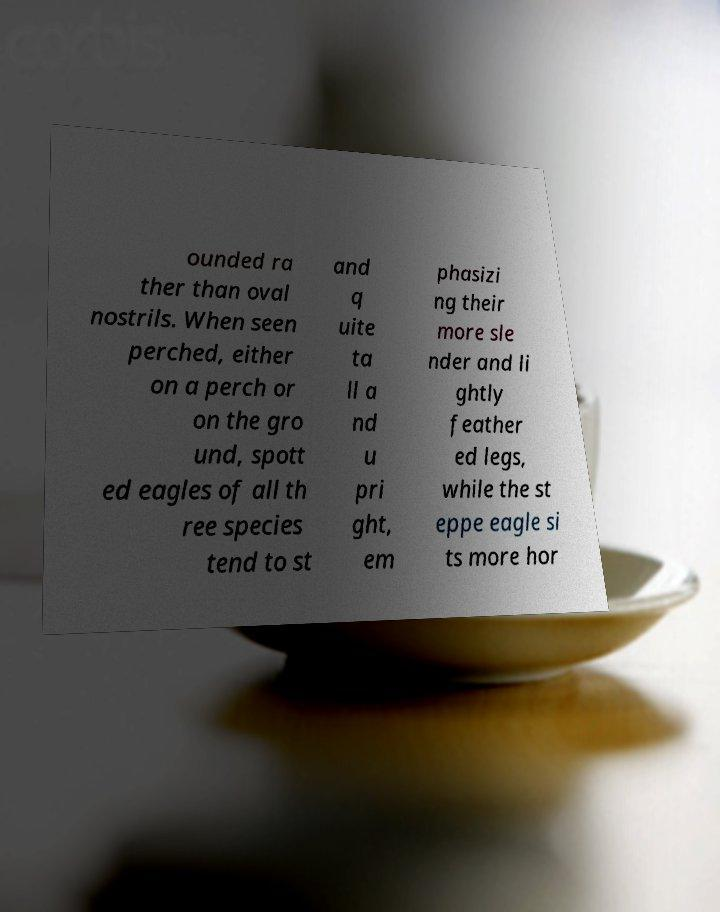Could you assist in decoding the text presented in this image and type it out clearly? ounded ra ther than oval nostrils. When seen perched, either on a perch or on the gro und, spott ed eagles of all th ree species tend to st and q uite ta ll a nd u pri ght, em phasizi ng their more sle nder and li ghtly feather ed legs, while the st eppe eagle si ts more hor 